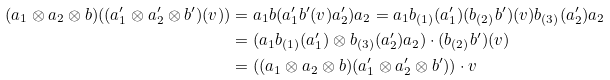<formula> <loc_0><loc_0><loc_500><loc_500>( a _ { 1 } \otimes a _ { 2 } \otimes b ) ( ( a _ { 1 } ^ { \prime } \otimes a _ { 2 } ^ { \prime } \otimes b ^ { \prime } ) ( v ) ) & = a _ { 1 } b ( a _ { 1 } ^ { \prime } b ^ { \prime } ( v ) a _ { 2 } ^ { \prime } ) a _ { 2 } = a _ { 1 } b _ { ( 1 ) } ( a _ { 1 } ^ { \prime } ) ( b _ { ( 2 ) } b ^ { \prime } ) ( v ) b _ { ( 3 ) } ( a _ { 2 } ^ { \prime } ) a _ { 2 } \\ & = ( a _ { 1 } b _ { ( 1 ) } ( a _ { 1 } ^ { \prime } ) \otimes b _ { ( 3 ) } ( a _ { 2 } ^ { \prime } ) a _ { 2 } ) \cdot ( b _ { ( 2 ) } b ^ { \prime } ) ( v ) \\ & = ( ( a _ { 1 } \otimes a _ { 2 } \otimes b ) ( a _ { 1 } ^ { \prime } \otimes a _ { 2 } ^ { \prime } \otimes b ^ { \prime } ) ) \cdot v</formula> 